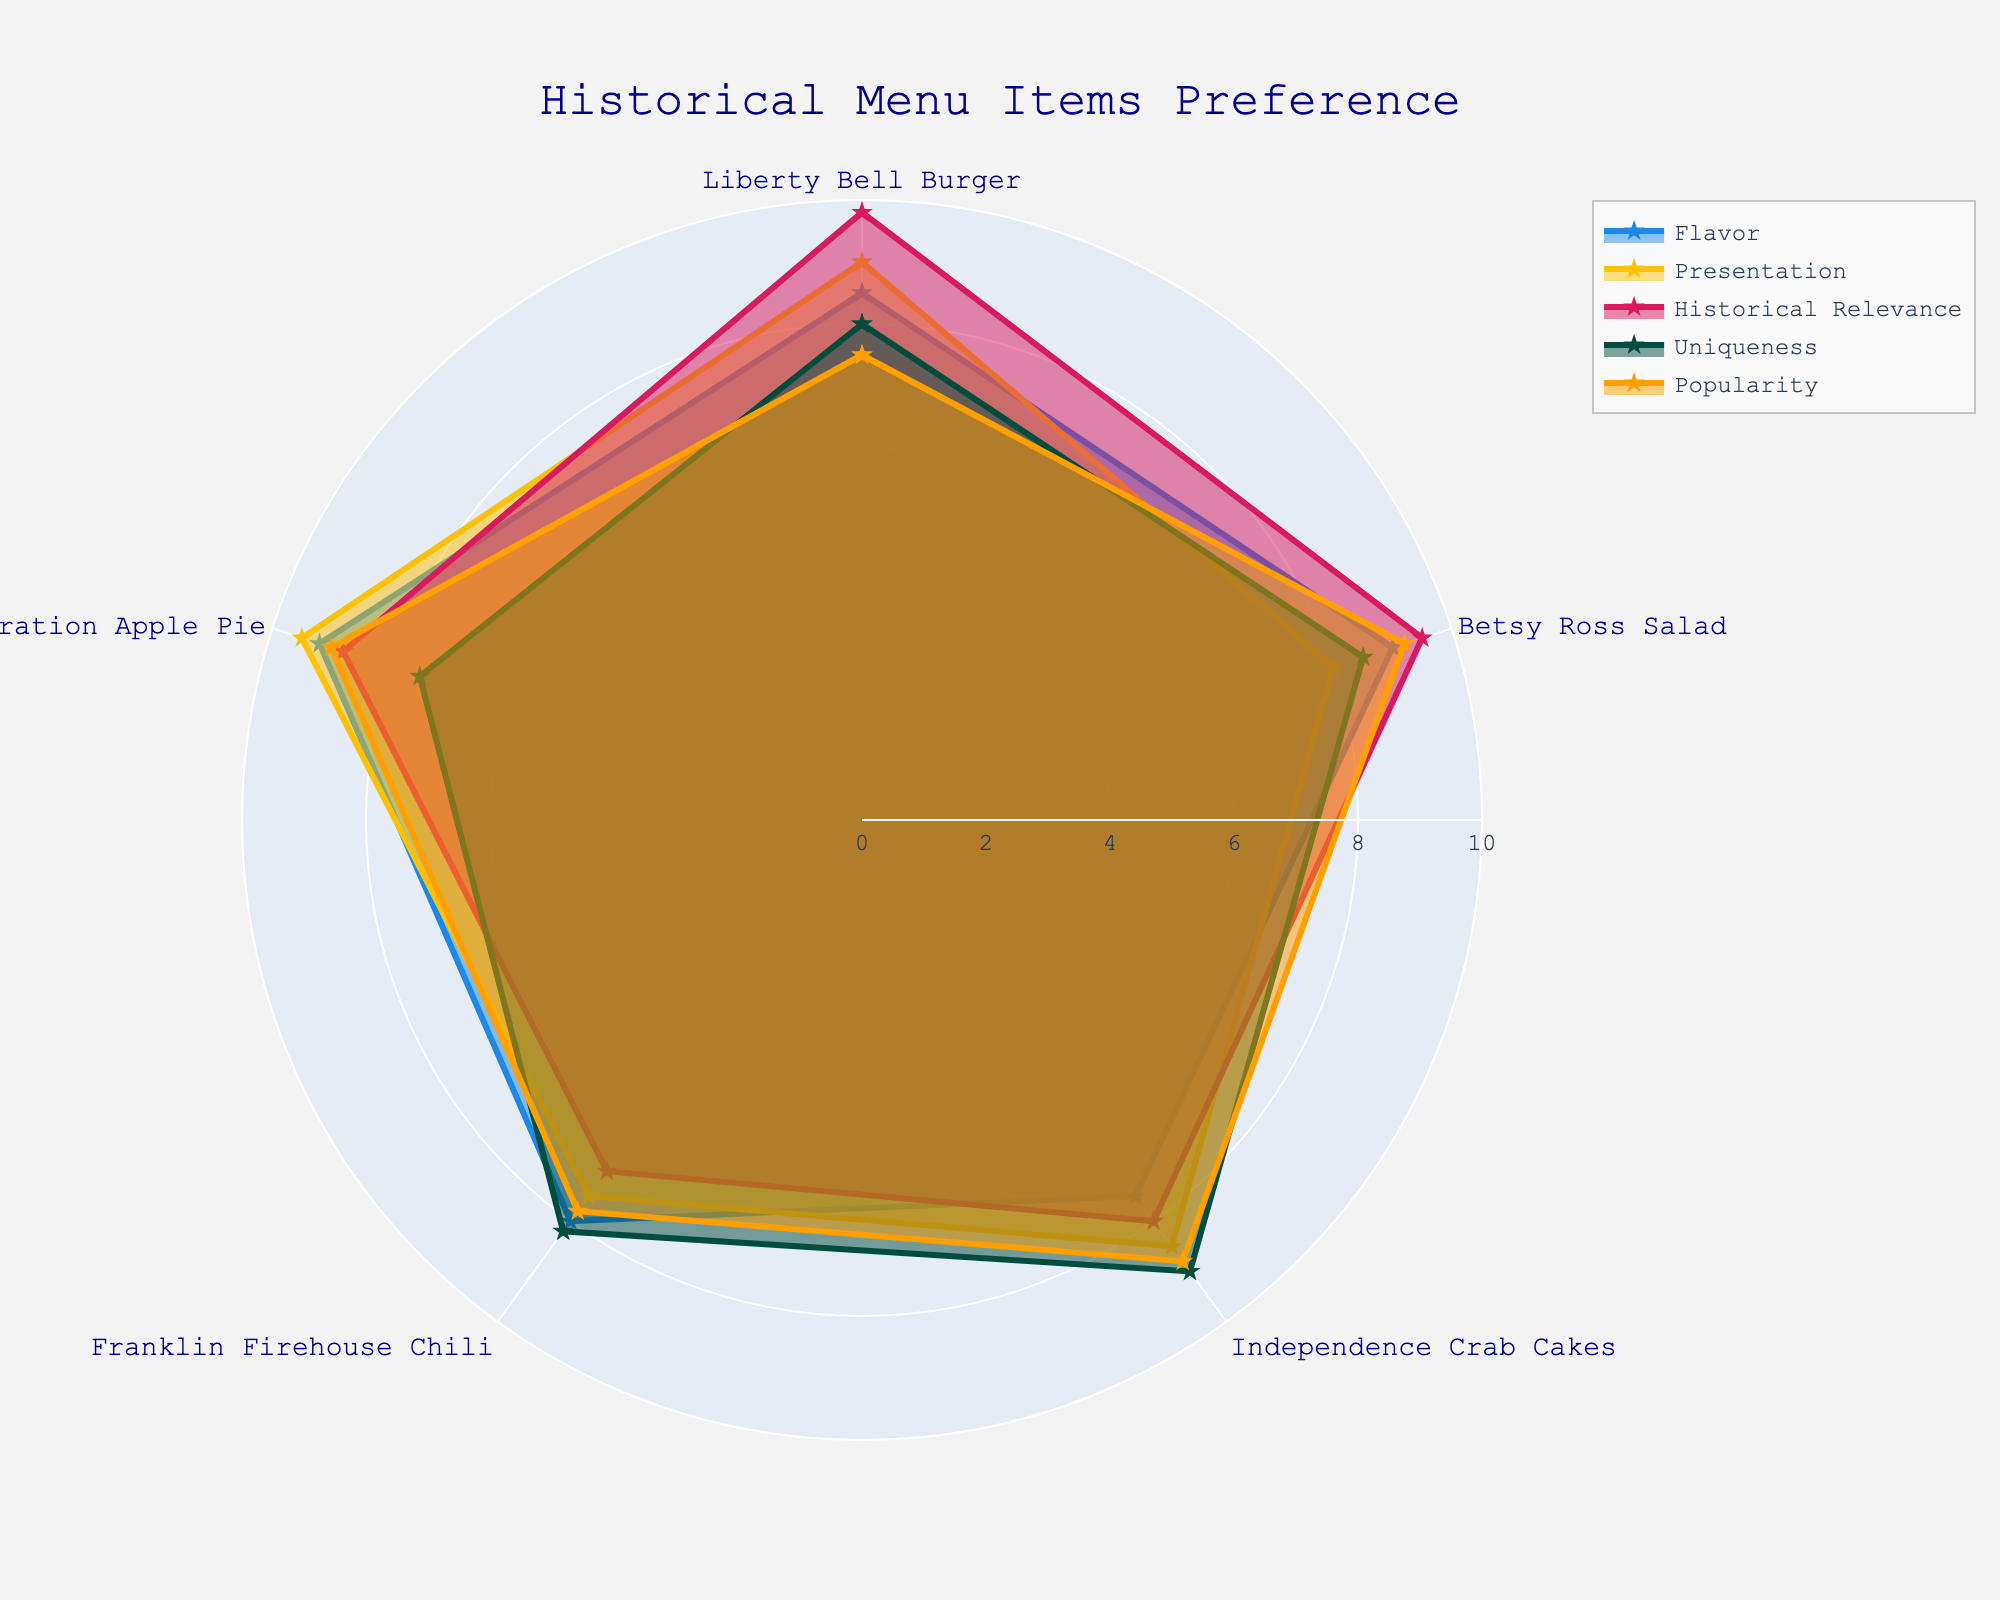how many different menu items are evaluated in the radar chart? There are 5 different menu items evaluated in the radar chart: Liberty Bell Burger, Betsy Ross Salad, Independence Crab Cakes, Franklin Firehouse Chili, and Declaration Apple Pie.
Answer: 5 what is the highest value for any attribute across all items? The highest value for any attribute across all items is 9.8 (Liberty Bell Burger for Historical Relevance).
Answer: 9.8 which item has the highest score for Presentation? The item with the highest score for Presentation is Declaration Apple Pie with a score of 9.5.
Answer: Declaration Apple Pie what is the average Flavor score across all items? To find the average Flavor score, sum all the scores and divide by the number of items: (8.5 + 9.0 + 7.5 + 8.0 + 9.2) / 5 = 42.2 / 5 = 8.44.
Answer: 8.44 which item has the lowest score for Historical Relevance? The item with the lowest score for Historical Relevance is Franklin Firehouse Chili with a score of 7.0.
Answer: Franklin Firehouse Chili consider both Popularity and Uniqueness, which item shows the most consistent scores for these two attributes? By comparing Popularity and Uniqueness scores, Betsy Ross Salad (Popularity 9.2, Uniqueness 8.5) has relatively close scores, showing the most consistency between these attributes.
Answer: Betsy Ross Salad among all items, which attribute generally has the highest scores? Comparing general trends, the attribute Historical Relevance usually has the highest scores across the items.
Answer: Historical Relevance which item has the widest range of scores between its best and worst attributes? Calculation for range: 
Liberty Bell Burger: 9.8 (Historical Relevance) - 7.5 (Popularity) = 2.3 
Betsy Ross Salad: 9.5 (Historical Relevance) - 8.0 (Presentation) = 1.5 
Independence Crab Cakes: 9.0 (Uniqueness) - 7.5 (Flavor) = 1.5 
Franklin Firehouse Chili: 8.2 (Uniqueness) - 7.0 (Historical Relevance) = 1.2 
Declaration Apple Pie: 9.5 (Presentation) - 7.5 (Uniqueness) = 2.0 
Liberty Bell Burger has the widest range of scores at 2.3.
Answer: Liberty Bell Burger How does the Flavor score of Franklin Firehouse Chili compare to that of Independence Crab Cakes? Franklin Firehouse Chili has a Flavor score of 8.0 while Independence Crab Cakes have a Flavor score of 7.5, so Franklin Firehouse Chili has a higher score.
Answer: Franklin Firehouse Chili has a higher score 